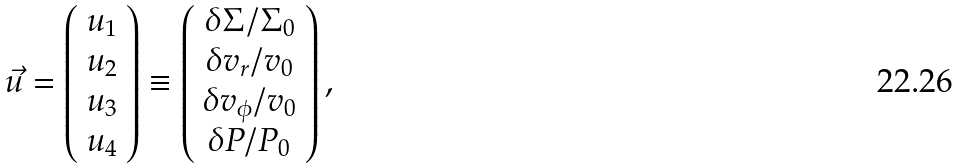Convert formula to latex. <formula><loc_0><loc_0><loc_500><loc_500>\vec { u } = \left ( \begin{array} { c } u _ { 1 } \\ u _ { 2 } \\ u _ { 3 } \\ u _ { 4 } \end{array} \right ) \equiv \left ( \begin{array} { c } \delta \Sigma / \Sigma _ { 0 } \\ \delta v _ { r } / v _ { 0 } \\ \delta v _ { \phi } / v _ { 0 } \\ \delta P / P _ { 0 } \end{array} \right ) ,</formula> 